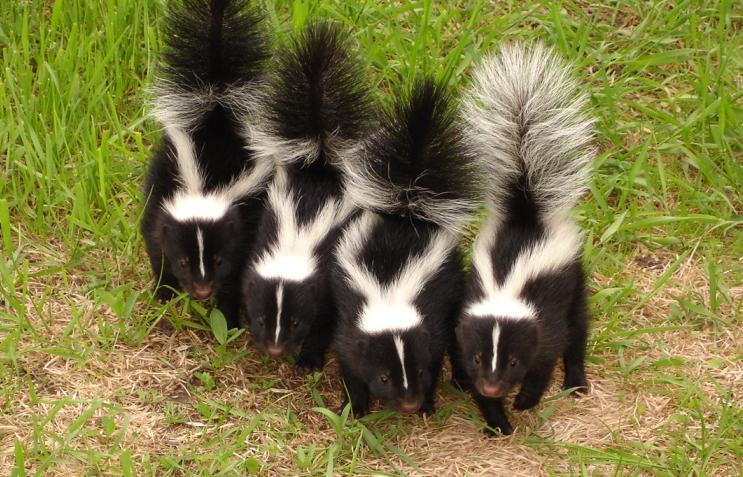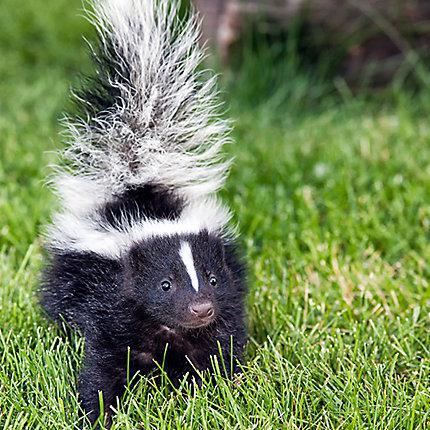The first image is the image on the left, the second image is the image on the right. Given the left and right images, does the statement "There are no more than four skunks in total." hold true? Answer yes or no. No. The first image is the image on the left, the second image is the image on the right. Analyze the images presented: Is the assertion "There is a single skunk in the right image." valid? Answer yes or no. Yes. 